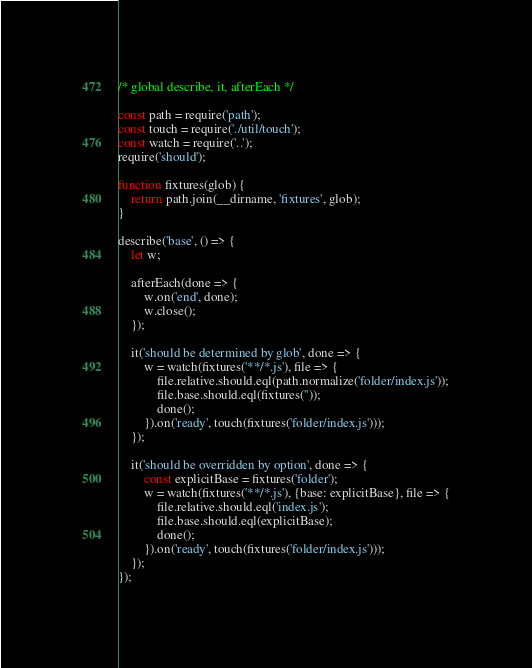Convert code to text. <code><loc_0><loc_0><loc_500><loc_500><_JavaScript_>/* global describe, it, afterEach */

const path = require('path');
const touch = require('./util/touch');
const watch = require('..');
require('should');

function fixtures(glob) {
	return path.join(__dirname, 'fixtures', glob);
}

describe('base', () => {
	let w;

	afterEach(done => {
		w.on('end', done);
		w.close();
	});

	it('should be determined by glob', done => {
		w = watch(fixtures('**/*.js'), file => {
			file.relative.should.eql(path.normalize('folder/index.js'));
			file.base.should.eql(fixtures(''));
			done();
		}).on('ready', touch(fixtures('folder/index.js')));
	});

	it('should be overridden by option', done => {
		const explicitBase = fixtures('folder');
		w = watch(fixtures('**/*.js'), {base: explicitBase}, file => {
			file.relative.should.eql('index.js');
			file.base.should.eql(explicitBase);
			done();
		}).on('ready', touch(fixtures('folder/index.js')));
	});
});
</code> 